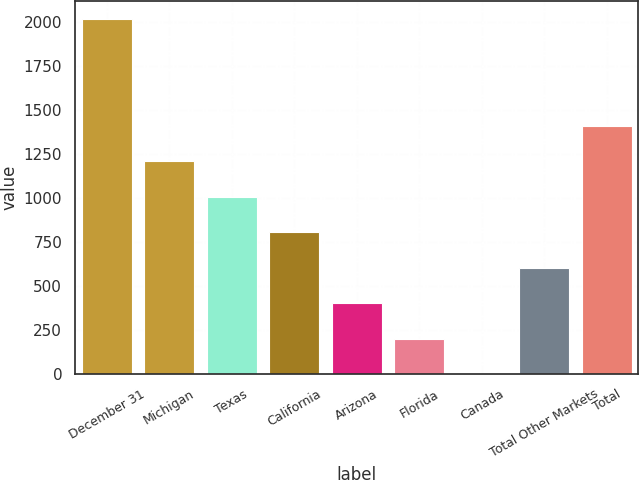Convert chart to OTSL. <chart><loc_0><loc_0><loc_500><loc_500><bar_chart><fcel>December 31<fcel>Michigan<fcel>Texas<fcel>California<fcel>Arizona<fcel>Florida<fcel>Canada<fcel>Total Other Markets<fcel>Total<nl><fcel>2018<fcel>1211.2<fcel>1009.5<fcel>807.8<fcel>404.4<fcel>202.7<fcel>1<fcel>606.1<fcel>1412.9<nl></chart> 